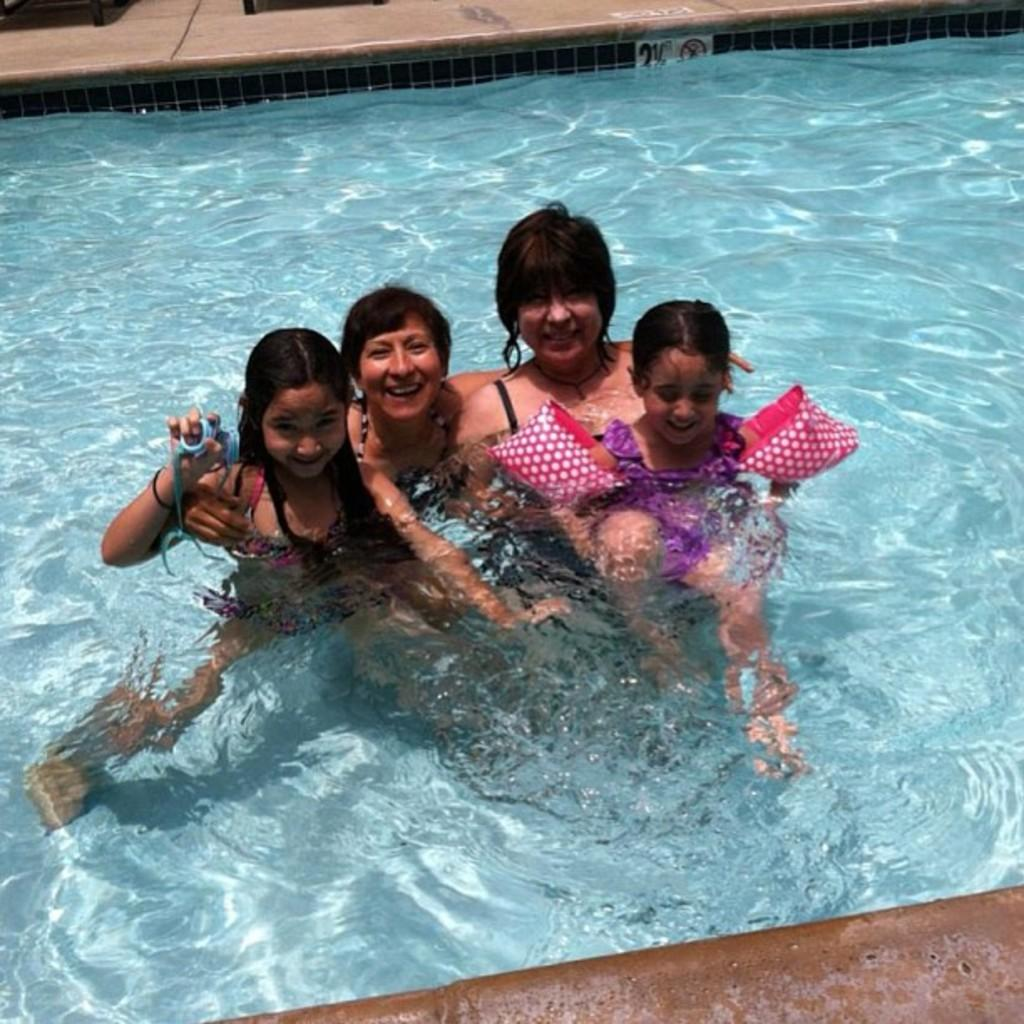What are the persons in the image doing? The persons in the image are in the water. What is the expression on their faces? The persons are smiling. What type of mark can be seen on the person's forehead in the image? There is no mark visible on the person's forehead in the image. What shape is the circle that the person is holding in the image? There is no circle present in the image. 